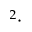Convert formula to latex. <formula><loc_0><loc_0><loc_500><loc_500>^ { 2 } \cdot</formula> 